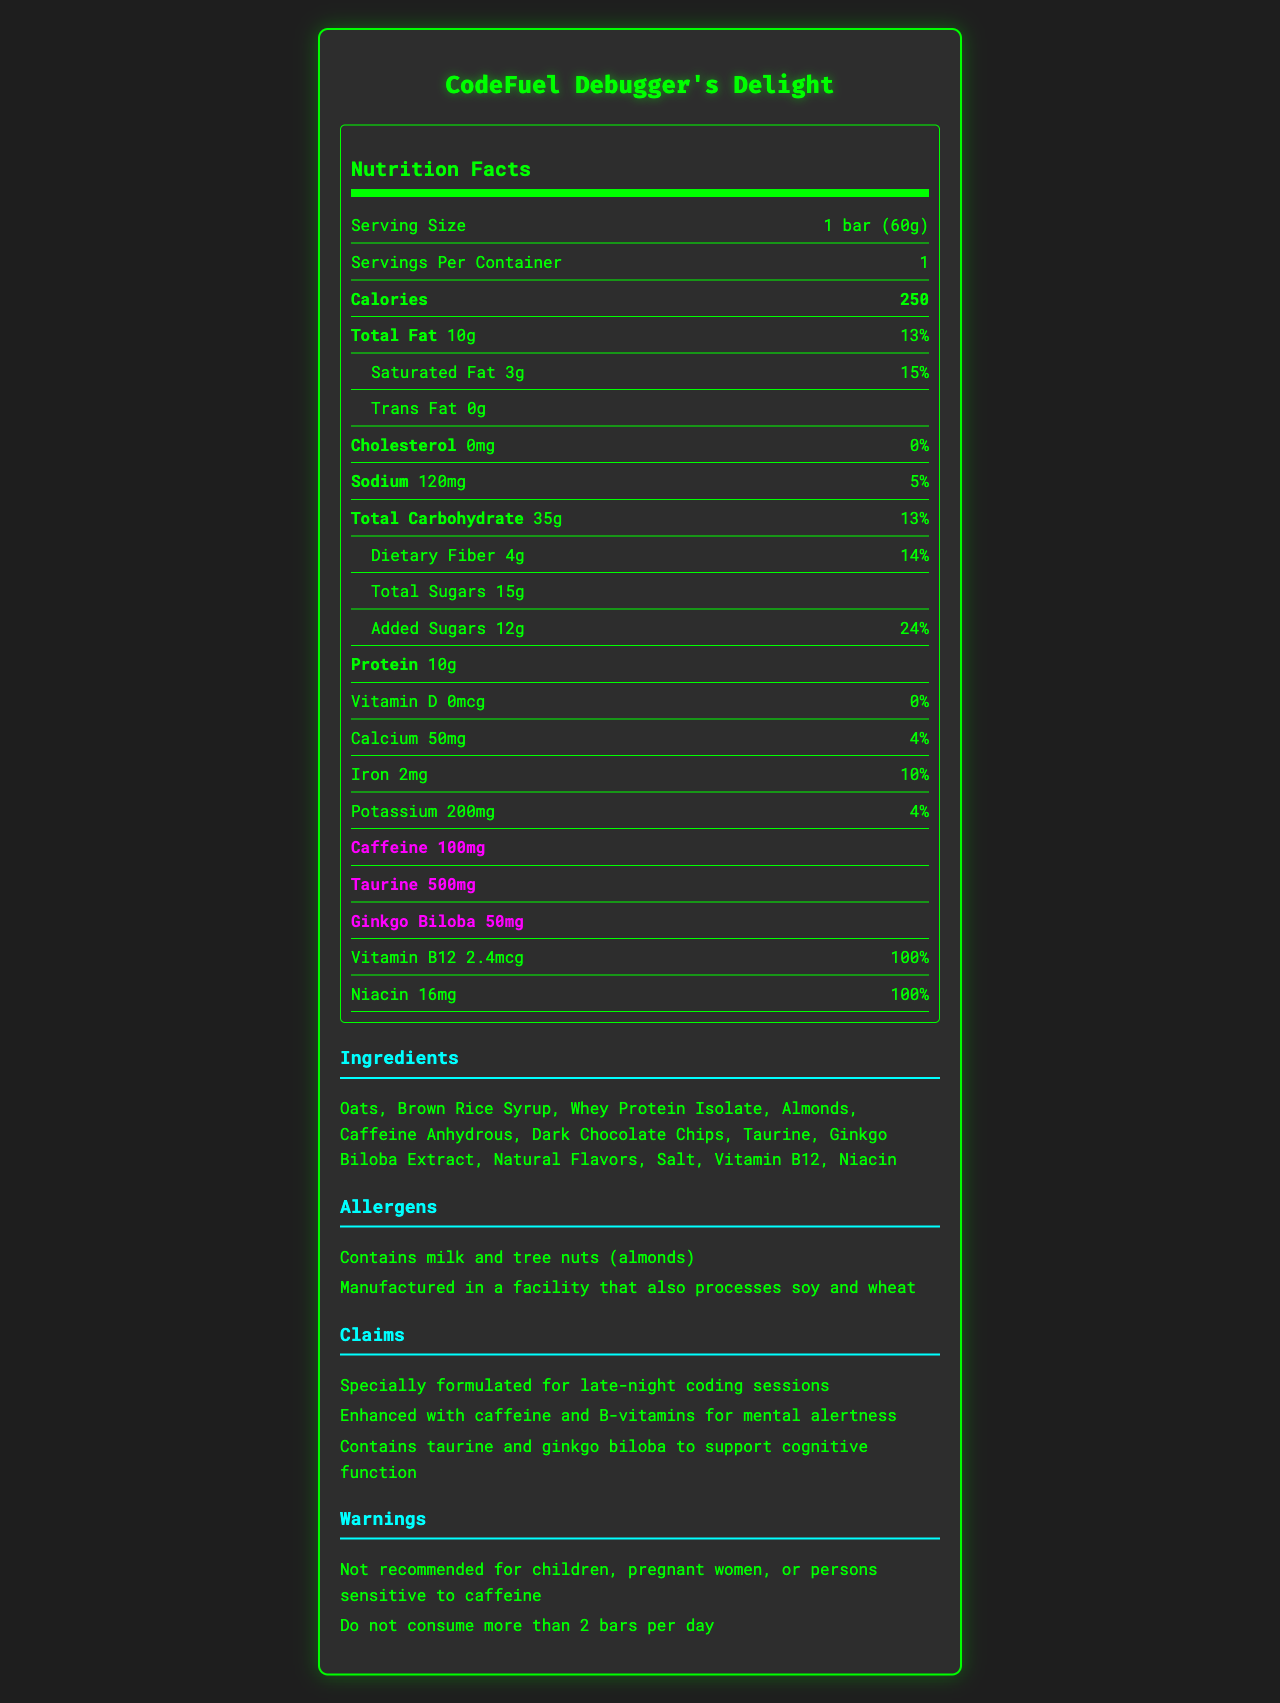what is the serving size? The serving size is explicitly stated as "1 bar (60g)" in the document's Nutrition Facts section.
Answer: 1 bar (60g) how many servings per container are there? The document shows that there is 1 serving per container.
Answer: 1 how many grams of total fat does the bar contain? The bar contains 10g of total fat as listed in the Nutrition Facts.
Answer: 10g what percentage of the daily value of saturated fat is in one bar? The Nutrition Facts indicate that one bar contains 15% of the daily value of saturated fat.
Answer: 15% how much dietary fiber is in the bar, and what is its daily value percentage? The bar contains 4g of dietary fiber, which is 14% of the daily value, as noted in the Nutrition Facts.
Answer: 4g, 14% which ingredient is the source of caffeine in the energy bar? The ingredient list shows that caffeine anhydrous is the source of caffeine in the bar.
Answer: Caffeine Anhydrous what is the total carbohydrate content in one bar? The Nutrition Facts section shows a total carbohydrate content of 35g per bar.
Answer: 35g which two ingredients indicate that the product is not dairy-free? The document states that the ingredients include "Whey Protein Isolate" and lists an allergen statement "Contains milk".
Answer: Whey Protein Isolate, Milk how much protein does the energy bar contain? The bar contains 10g of protein as indicated in the Nutrition Facts.
Answer: 10g How many milligrams of caffeine are in one bar? The amount of caffeine in one bar is 100mg, according to the Nutrition Facts.
Answer: 100mg Based on the document, who should avoid eating this product? A. Vegetarians B. Children and pregnant women C. Individuals with a gluten allergy The warning statements advise that children and pregnant women should avoid consuming this product.
Answer: B which vitamins in the bar aid with mental alertness? A. Vitamin D and Niacin B. Vitamin B12 and Niacin C. Calcium and Iron D. Potassium and Vitamin B12 The claim statements mention that the bar is enhanced with B-vitamins, such as Vitamin B12 and Niacin, for mental alertness.
Answer: B is this energy bar suitable for people with nut allergies? The allergen statement shows that the bar contains tree nuts (almonds), making it unsuitable for people with nut allergies.
Answer: No Summarize the main idea of the document. The document presents comprehensive nutrition and ingredient information for the energy bar, emphasizing its use for mental focus during coding sessions and including necessary warnings and allergen information.
Answer: The document is a nutrition facts label for the "CodeFuel Debugger's Delight" energy bar, which is specially formulated for late-night debugging sessions. It contains detailed nutritional information, ingredients, allergens, claim statements, and warnings, highlighting its composition and benefits such as caffeine and B-vitamins for mental alertness. what is the total sugar content in one bar? The total sugar content in one bar is 15g, as stated in the Nutrition Facts.
Answer: 15g How much taurine does the energy bar contain? The Nutrition Facts show that the bar contains 500mg of taurine.
Answer: 500mg Does the document state the bar's manufacturing facility processes soy and wheat? The allergen section states that the bar is manufactured in a facility that also processes soy and wheat.
Answer: Yes What other information would you need to determine whether this bar fits within your daily calorie limit? The document specifies the calories per bar but does not provide your personal daily calorie limit for comparison.
Answer: Not enough information 